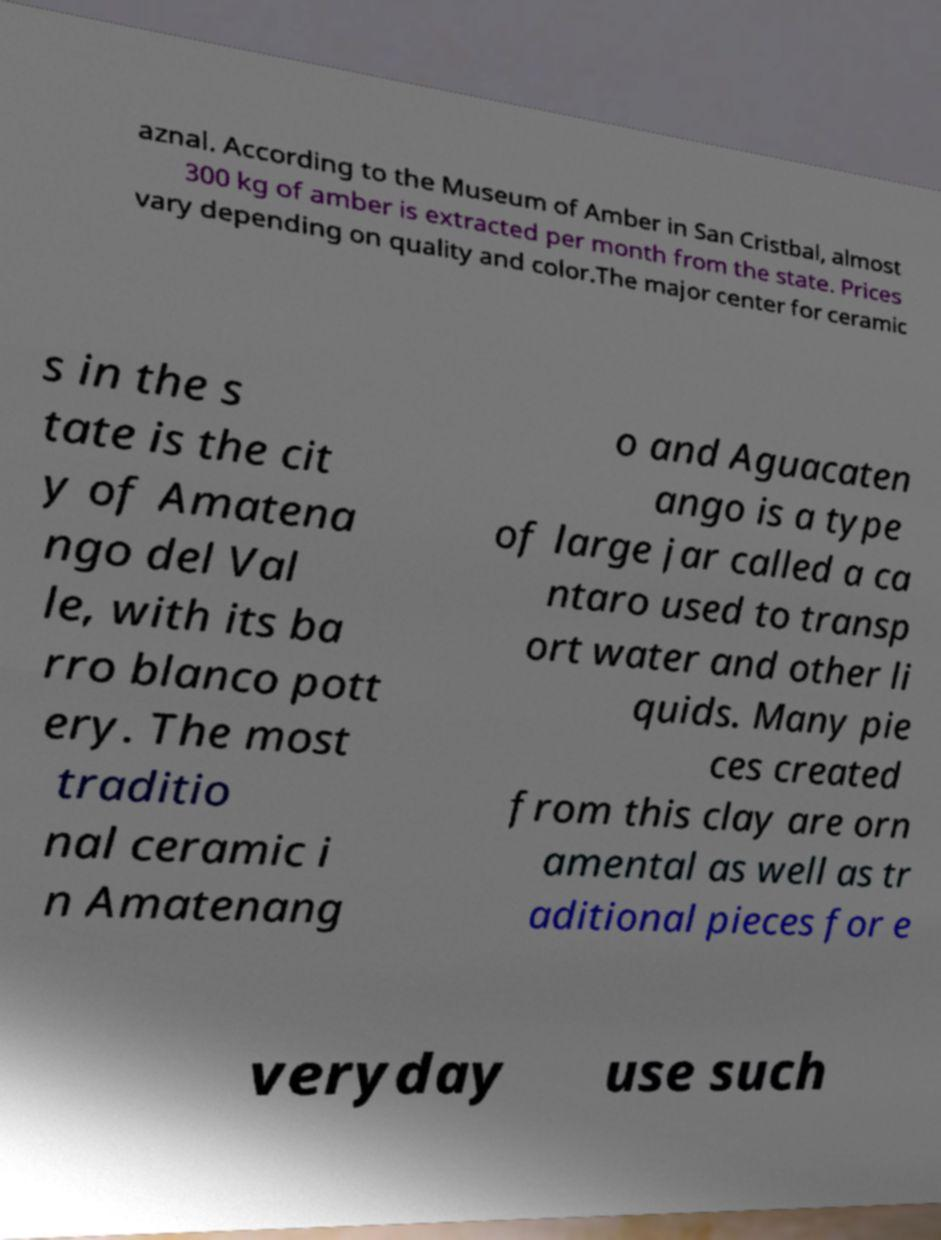For documentation purposes, I need the text within this image transcribed. Could you provide that? aznal. According to the Museum of Amber in San Cristbal, almost 300 kg of amber is extracted per month from the state. Prices vary depending on quality and color.The major center for ceramic s in the s tate is the cit y of Amatena ngo del Val le, with its ba rro blanco pott ery. The most traditio nal ceramic i n Amatenang o and Aguacaten ango is a type of large jar called a ca ntaro used to transp ort water and other li quids. Many pie ces created from this clay are orn amental as well as tr aditional pieces for e veryday use such 